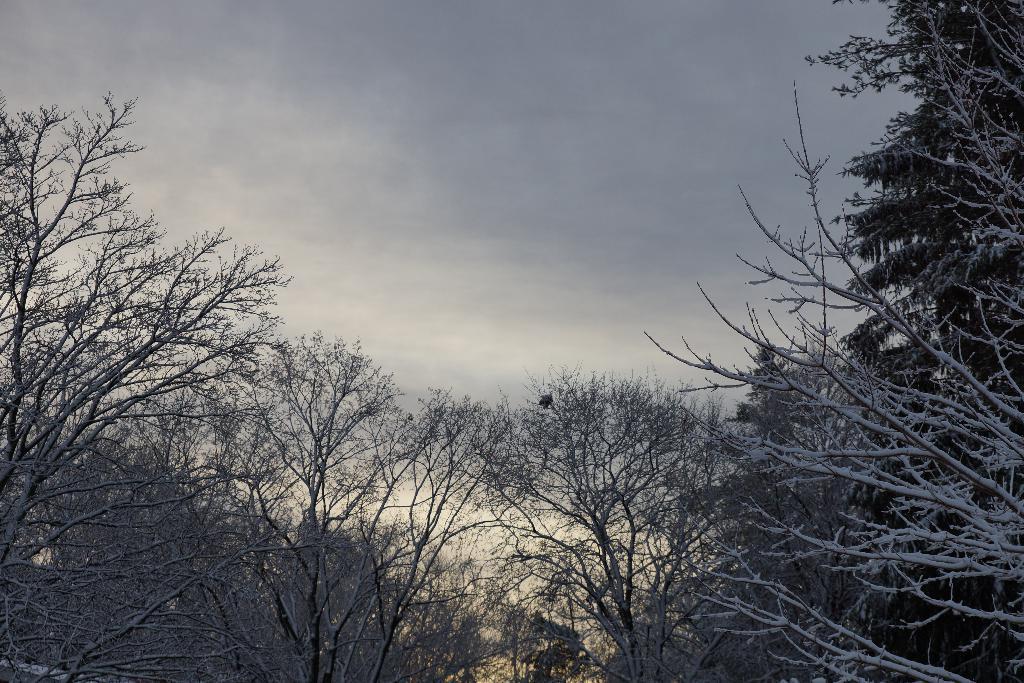Can you describe this image briefly? In the center of the image there are trees. In the background we can see sky. 